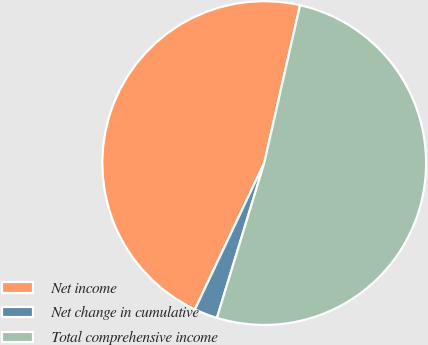Convert chart. <chart><loc_0><loc_0><loc_500><loc_500><pie_chart><fcel>Net income<fcel>Net change in cumulative<fcel>Total comprehensive income<nl><fcel>46.51%<fcel>2.32%<fcel>51.16%<nl></chart> 